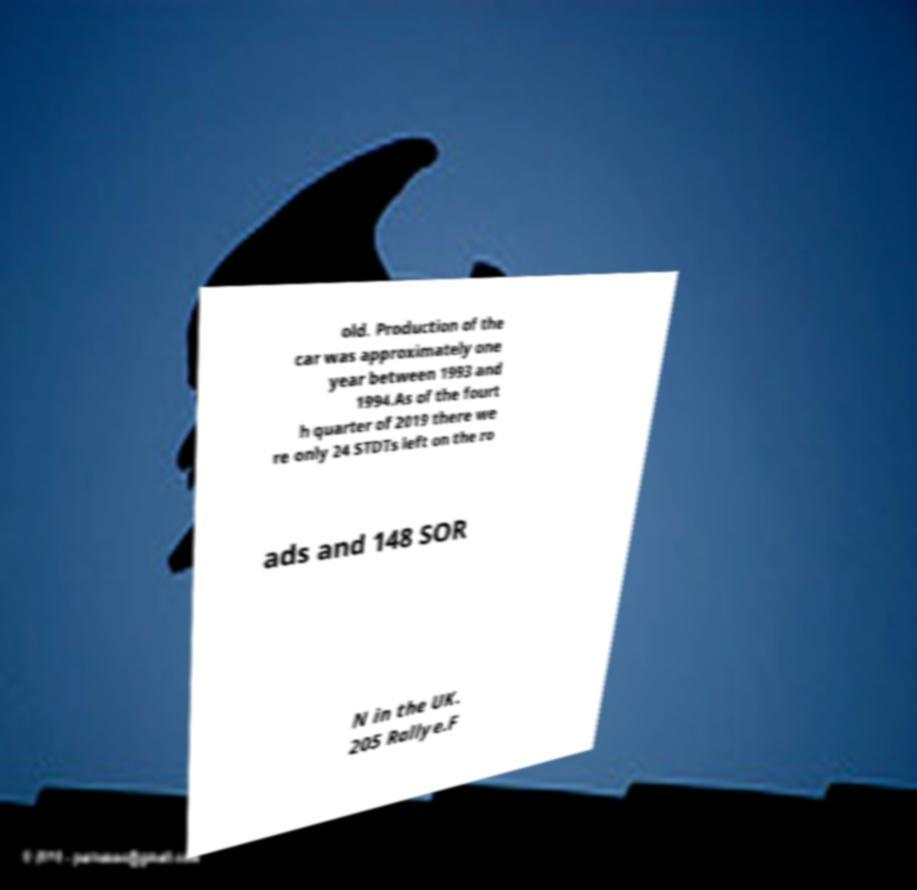Could you assist in decoding the text presented in this image and type it out clearly? old. Production of the car was approximately one year between 1993 and 1994.As of the fourt h quarter of 2019 there we re only 24 STDTs left on the ro ads and 148 SOR N in the UK. 205 Rallye.F 